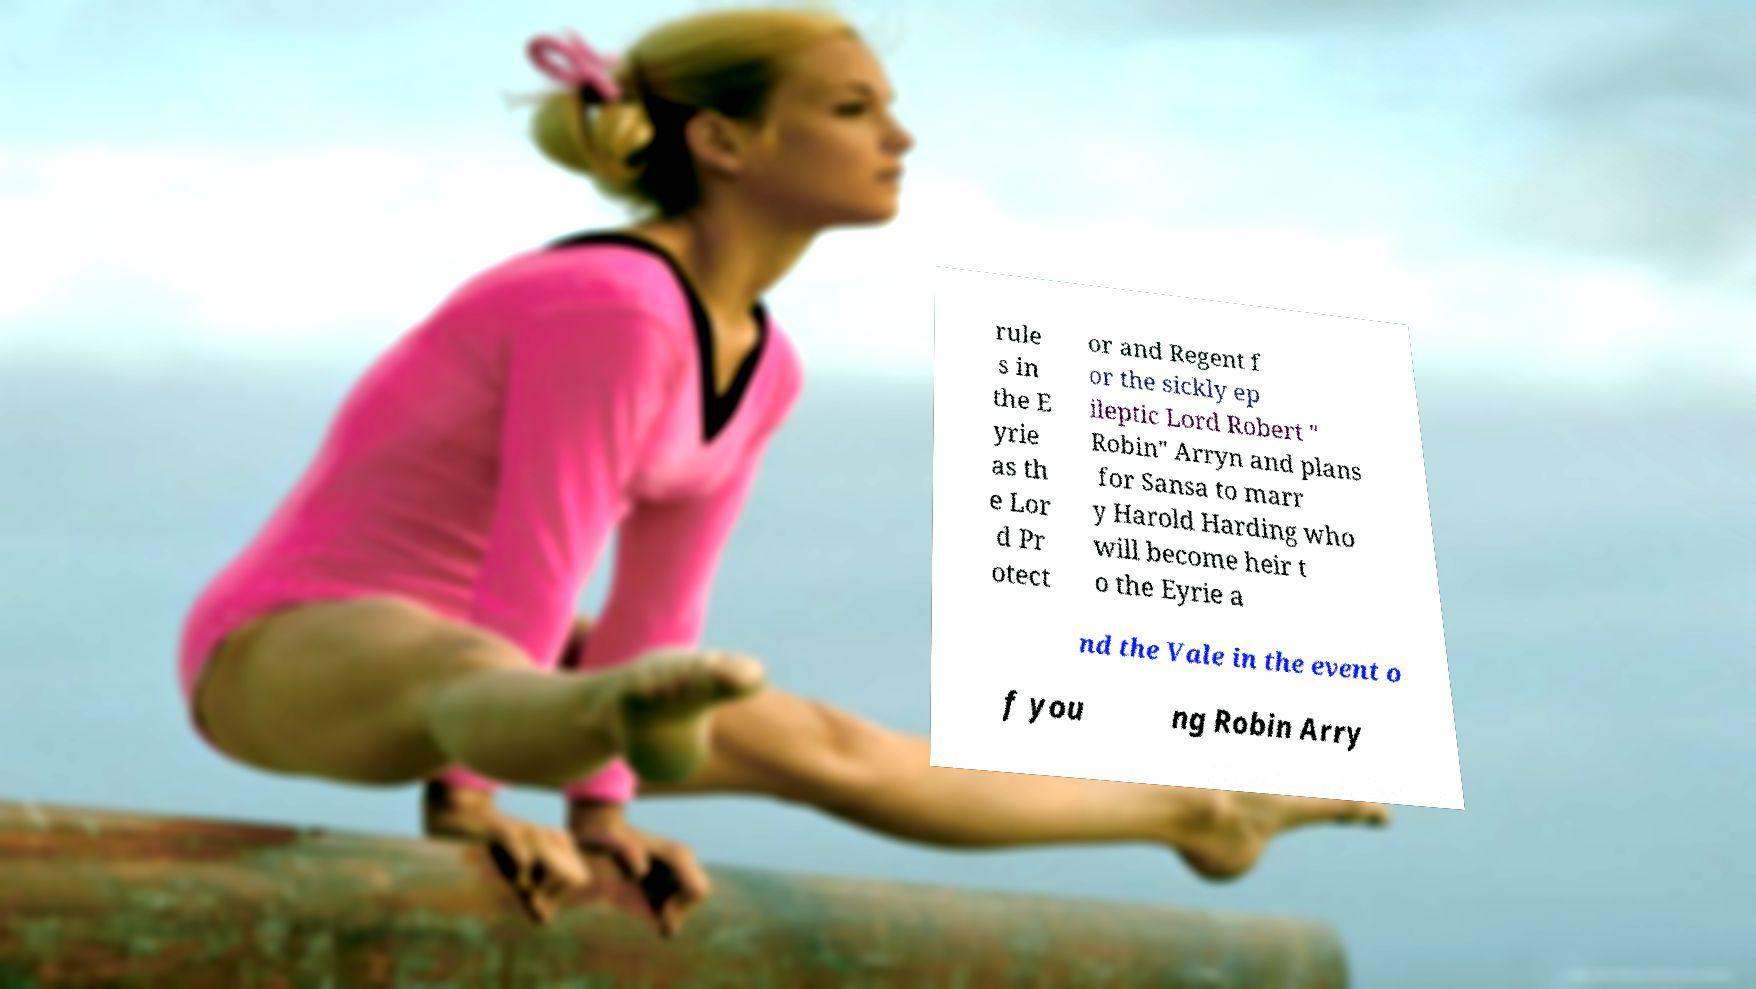Please identify and transcribe the text found in this image. rule s in the E yrie as th e Lor d Pr otect or and Regent f or the sickly ep ileptic Lord Robert " Robin" Arryn and plans for Sansa to marr y Harold Harding who will become heir t o the Eyrie a nd the Vale in the event o f you ng Robin Arry 